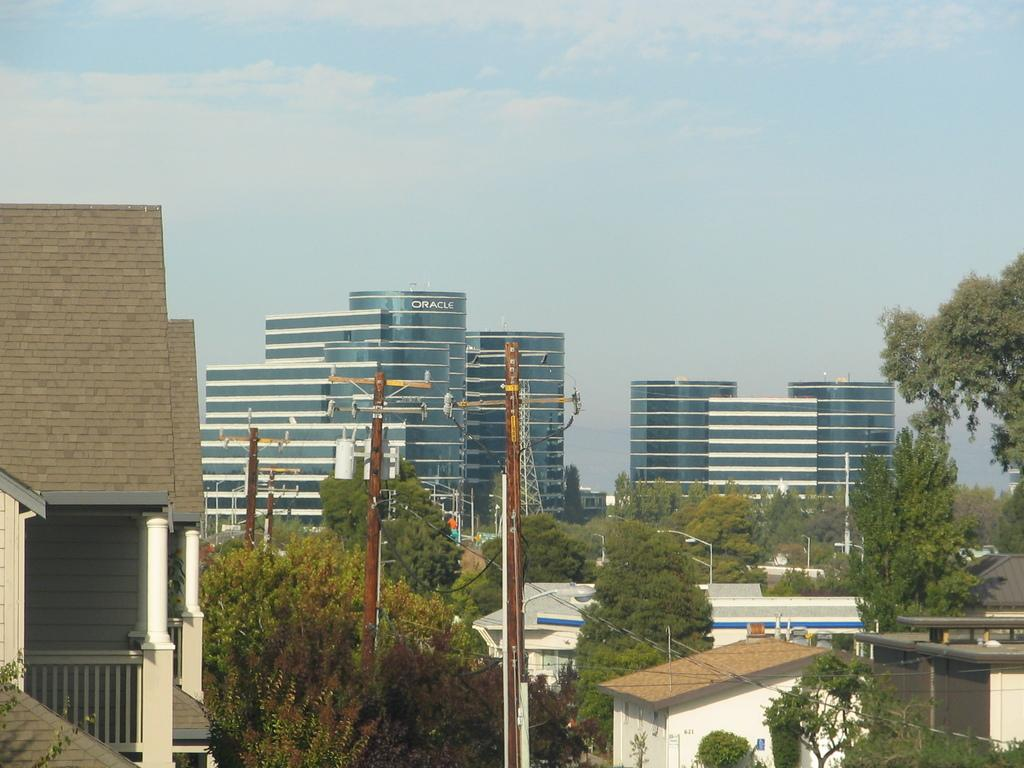<image>
Share a concise interpretation of the image provided. a skyline overlooking ORACLE building in the distance 